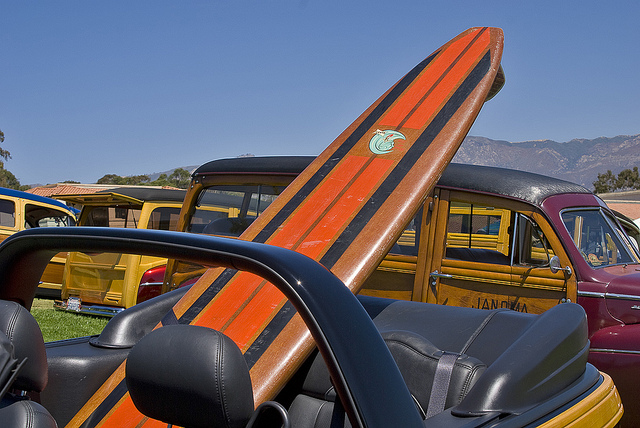<image>Are those Woodys is the background? I am not sure. They could be Woodys in the background. Are those Woodys is the background? I don't know if those are Woodys in the background. It is possible. 